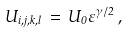Convert formula to latex. <formula><loc_0><loc_0><loc_500><loc_500>U _ { i , j , k , l } \, = \, U _ { 0 } \varepsilon ^ { \gamma / 2 } \, ,</formula> 